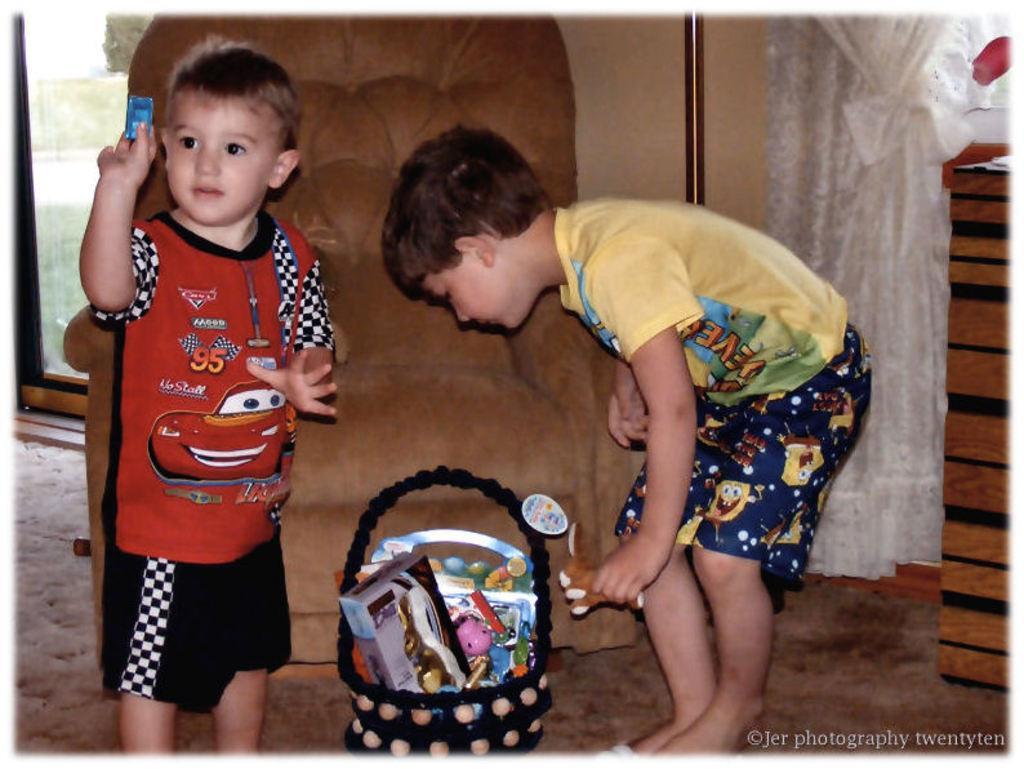How would you summarize this image in a sentence or two? In this picture we can see two kids are standing, at the bottom there is a basket, we can see toys present in the basket, on the right side there is a curtain, on the left side we can see a glass door, from the glass we can see grass. 